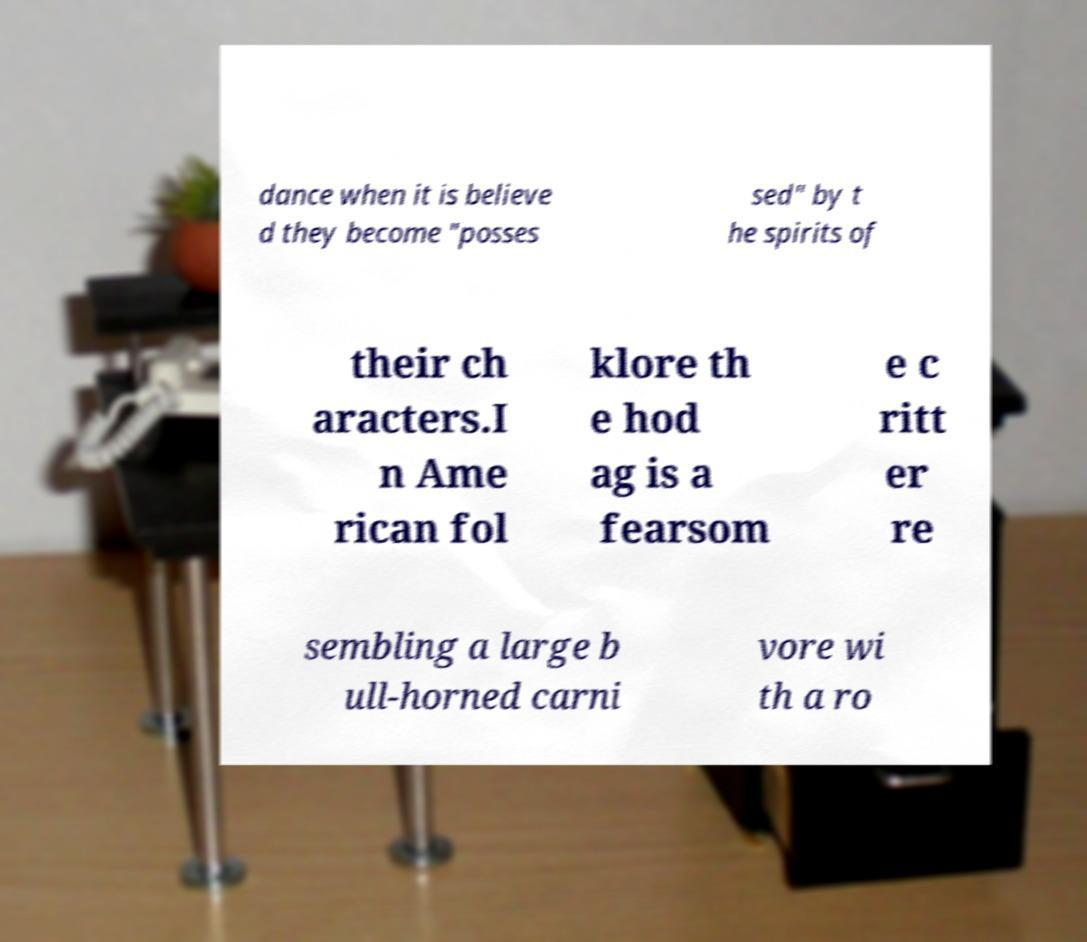What messages or text are displayed in this image? I need them in a readable, typed format. dance when it is believe d they become "posses sed" by t he spirits of their ch aracters.I n Ame rican fol klore th e hod ag is a fearsom e c ritt er re sembling a large b ull-horned carni vore wi th a ro 